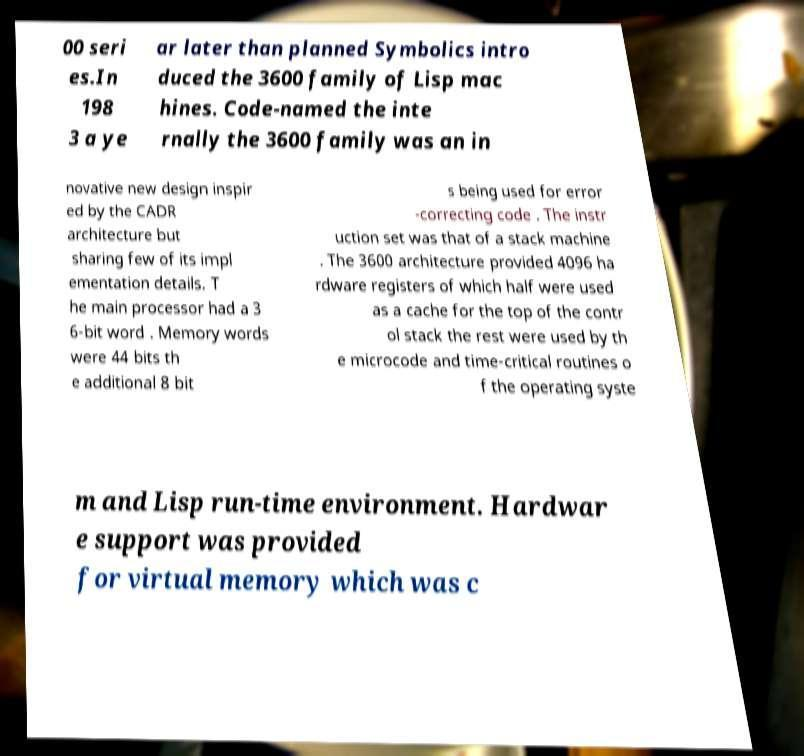Could you extract and type out the text from this image? 00 seri es.In 198 3 a ye ar later than planned Symbolics intro duced the 3600 family of Lisp mac hines. Code-named the inte rnally the 3600 family was an in novative new design inspir ed by the CADR architecture but sharing few of its impl ementation details. T he main processor had a 3 6-bit word . Memory words were 44 bits th e additional 8 bit s being used for error -correcting code . The instr uction set was that of a stack machine . The 3600 architecture provided 4096 ha rdware registers of which half were used as a cache for the top of the contr ol stack the rest were used by th e microcode and time-critical routines o f the operating syste m and Lisp run-time environment. Hardwar e support was provided for virtual memory which was c 